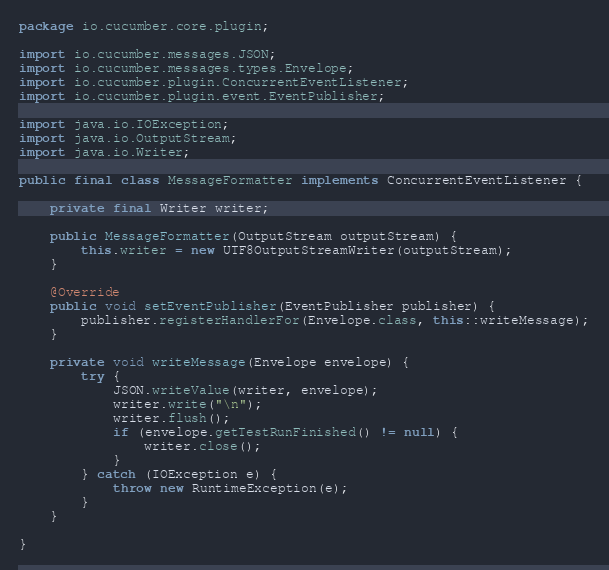<code> <loc_0><loc_0><loc_500><loc_500><_Java_>package io.cucumber.core.plugin;

import io.cucumber.messages.JSON;
import io.cucumber.messages.types.Envelope;
import io.cucumber.plugin.ConcurrentEventListener;
import io.cucumber.plugin.event.EventPublisher;

import java.io.IOException;
import java.io.OutputStream;
import java.io.Writer;

public final class MessageFormatter implements ConcurrentEventListener {

    private final Writer writer;

    public MessageFormatter(OutputStream outputStream) {
        this.writer = new UTF8OutputStreamWriter(outputStream);
    }

    @Override
    public void setEventPublisher(EventPublisher publisher) {
        publisher.registerHandlerFor(Envelope.class, this::writeMessage);
    }

    private void writeMessage(Envelope envelope) {
        try {
            JSON.writeValue(writer, envelope);
            writer.write("\n");
            writer.flush();
            if (envelope.getTestRunFinished() != null) {
                writer.close();
            }
        } catch (IOException e) {
            throw new RuntimeException(e);
        }
    }

}
</code> 